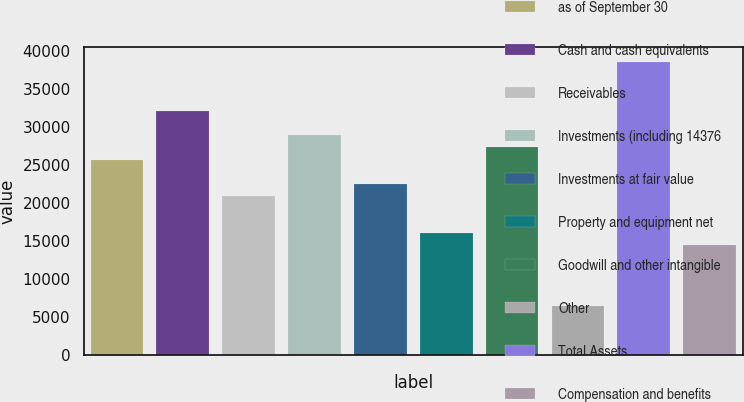Convert chart to OTSL. <chart><loc_0><loc_0><loc_500><loc_500><bar_chart><fcel>as of September 30<fcel>Cash and cash equivalents<fcel>Receivables<fcel>Investments (including 14376<fcel>Investments at fair value<fcel>Property and equipment net<fcel>Goodwill and other intangible<fcel>Other<fcel>Total Assets<fcel>Compensation and benefits<nl><fcel>25723.9<fcel>32140.6<fcel>20911.3<fcel>28932.2<fcel>22515.5<fcel>16098.8<fcel>27328.1<fcel>6473.72<fcel>38557.3<fcel>14494.6<nl></chart> 